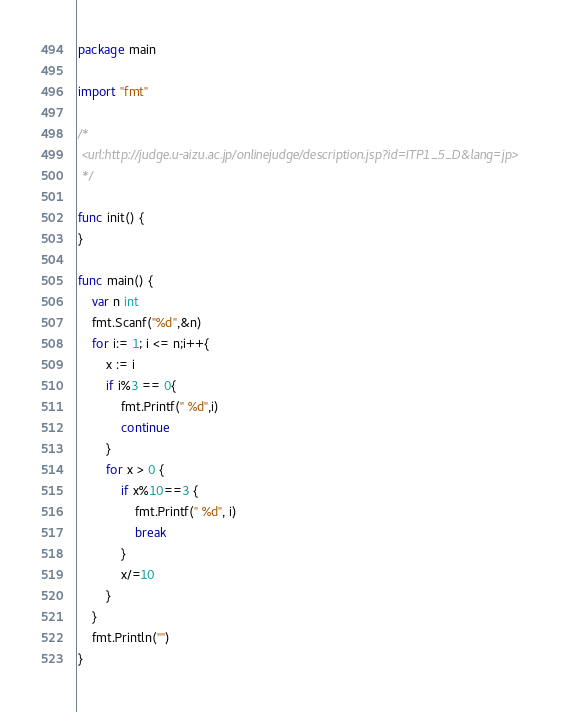Convert code to text. <code><loc_0><loc_0><loc_500><loc_500><_Go_>package main

import "fmt"

/*
 <url:http://judge.u-aizu.ac.jp/onlinejudge/description.jsp?id=ITP1_5_D&lang=jp>
 */

func init() {
}

func main() {
	var n int
	fmt.Scanf("%d",&n)
	for i:= 1; i <= n;i++{
		x := i
		if i%3 == 0{
			fmt.Printf(" %d",i)
			continue
		}
		for x > 0 {
			if x%10==3 {
				fmt.Printf(" %d", i)
				break
			}
			x/=10
		}
	}
	fmt.Println("")
}</code> 